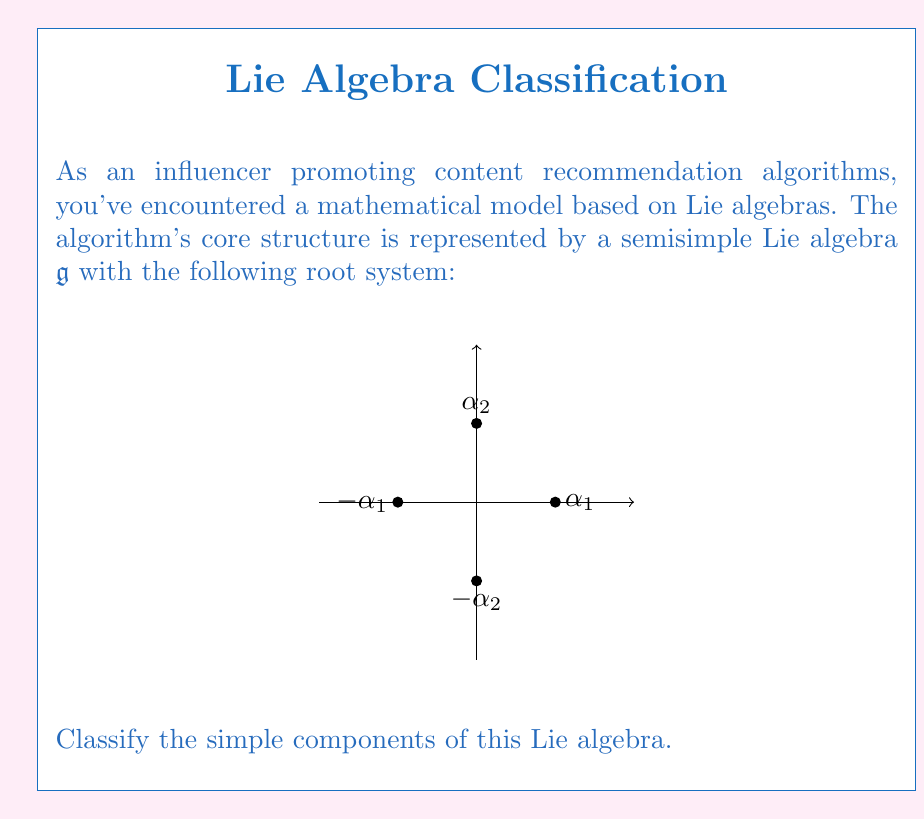Solve this math problem. Let's approach this step-by-step:

1) First, we need to identify the root system. The given diagram shows four roots: $\alpha_1$, $\alpha_2$, $-\alpha_1$, and $-\alpha_2$. This forms a closed root system under addition and subtraction.

2) The root system is two-dimensional, which indicates that the rank of the Lie algebra is 2.

3) The roots form a square pattern, which is characteristic of the $A_1 \times A_1$ root system.

4) In Lie algebra classification:
   - $A_1$ corresponds to $\mathfrak{sl}(2,\mathbb{C})$
   - The direct product $A_1 \times A_1$ corresponds to $\mathfrak{sl}(2,\mathbb{C}) \oplus \mathfrak{sl}(2,\mathbb{C})$

5) The Lie algebra $\mathfrak{sl}(2,\mathbb{C})$ is the special linear algebra of $2 \times 2$ matrices with trace zero.

6) The direct sum $\mathfrak{sl}(2,\mathbb{C}) \oplus \mathfrak{sl}(2,\mathbb{C})$ indicates that our Lie algebra $\mathfrak{g}$ is composed of two independent copies of $\mathfrak{sl}(2,\mathbb{C})$.

Therefore, the semisimple Lie algebra $\mathfrak{g}$ decomposes into two simple components, each isomorphic to $\mathfrak{sl}(2,\mathbb{C})$.
Answer: $\mathfrak{g} \cong \mathfrak{sl}(2,\mathbb{C}) \oplus \mathfrak{sl}(2,\mathbb{C})$ 